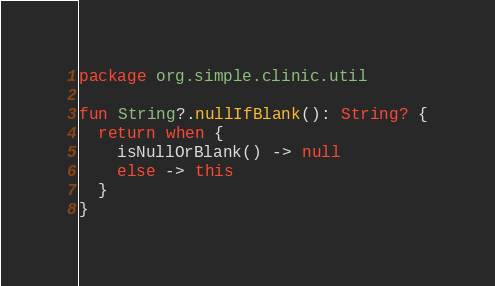<code> <loc_0><loc_0><loc_500><loc_500><_Kotlin_>package org.simple.clinic.util

fun String?.nullIfBlank(): String? {
  return when {
    isNullOrBlank() -> null
    else -> this
  }
}
</code> 